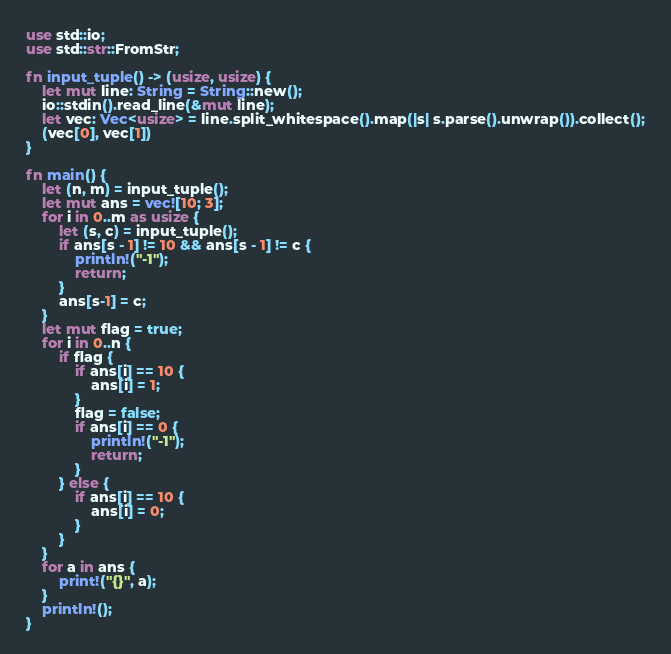<code> <loc_0><loc_0><loc_500><loc_500><_Rust_>use std::io;
use std::str::FromStr;

fn input_tuple() -> (usize, usize) {
    let mut line: String = String::new();
    io::stdin().read_line(&mut line);
    let vec: Vec<usize> = line.split_whitespace().map(|s| s.parse().unwrap()).collect();
    (vec[0], vec[1])
}

fn main() {
    let (n, m) = input_tuple();
    let mut ans = vec![10; 3];
    for i in 0..m as usize {
        let (s, c) = input_tuple();
        if ans[s - 1] != 10 && ans[s - 1] != c {
            println!("-1");
            return;
        }
        ans[s-1] = c;
    }
    let mut flag = true;
    for i in 0..n {
        if flag {
            if ans[i] == 10 {
                ans[i] = 1;
            }
            flag = false;
            if ans[i] == 0 {
                println!("-1");
                return;
            }
        } else {
            if ans[i] == 10 {
                ans[i] = 0;
            }
        }
    }
    for a in ans {
        print!("{}", a);
    }
    println!();
}
</code> 